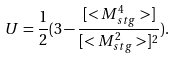<formula> <loc_0><loc_0><loc_500><loc_500>U = \frac { 1 } { 2 } ( 3 - \frac { [ < M _ { s t g } ^ { 4 } > ] } { [ < M _ { s t g } ^ { 2 } > ] ^ { 2 } } ) .</formula> 